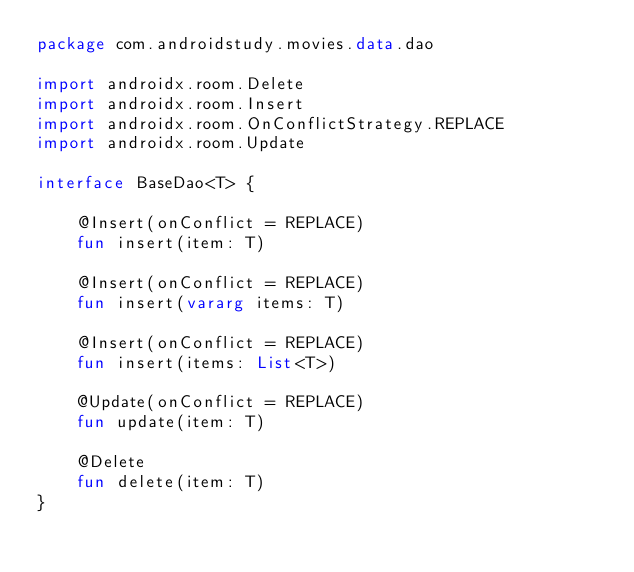Convert code to text. <code><loc_0><loc_0><loc_500><loc_500><_Kotlin_>package com.androidstudy.movies.data.dao

import androidx.room.Delete
import androidx.room.Insert
import androidx.room.OnConflictStrategy.REPLACE
import androidx.room.Update

interface BaseDao<T> {

    @Insert(onConflict = REPLACE)
    fun insert(item: T)

    @Insert(onConflict = REPLACE)
    fun insert(vararg items: T)

    @Insert(onConflict = REPLACE)
    fun insert(items: List<T>)

    @Update(onConflict = REPLACE)
    fun update(item: T)

    @Delete
    fun delete(item: T)
}</code> 